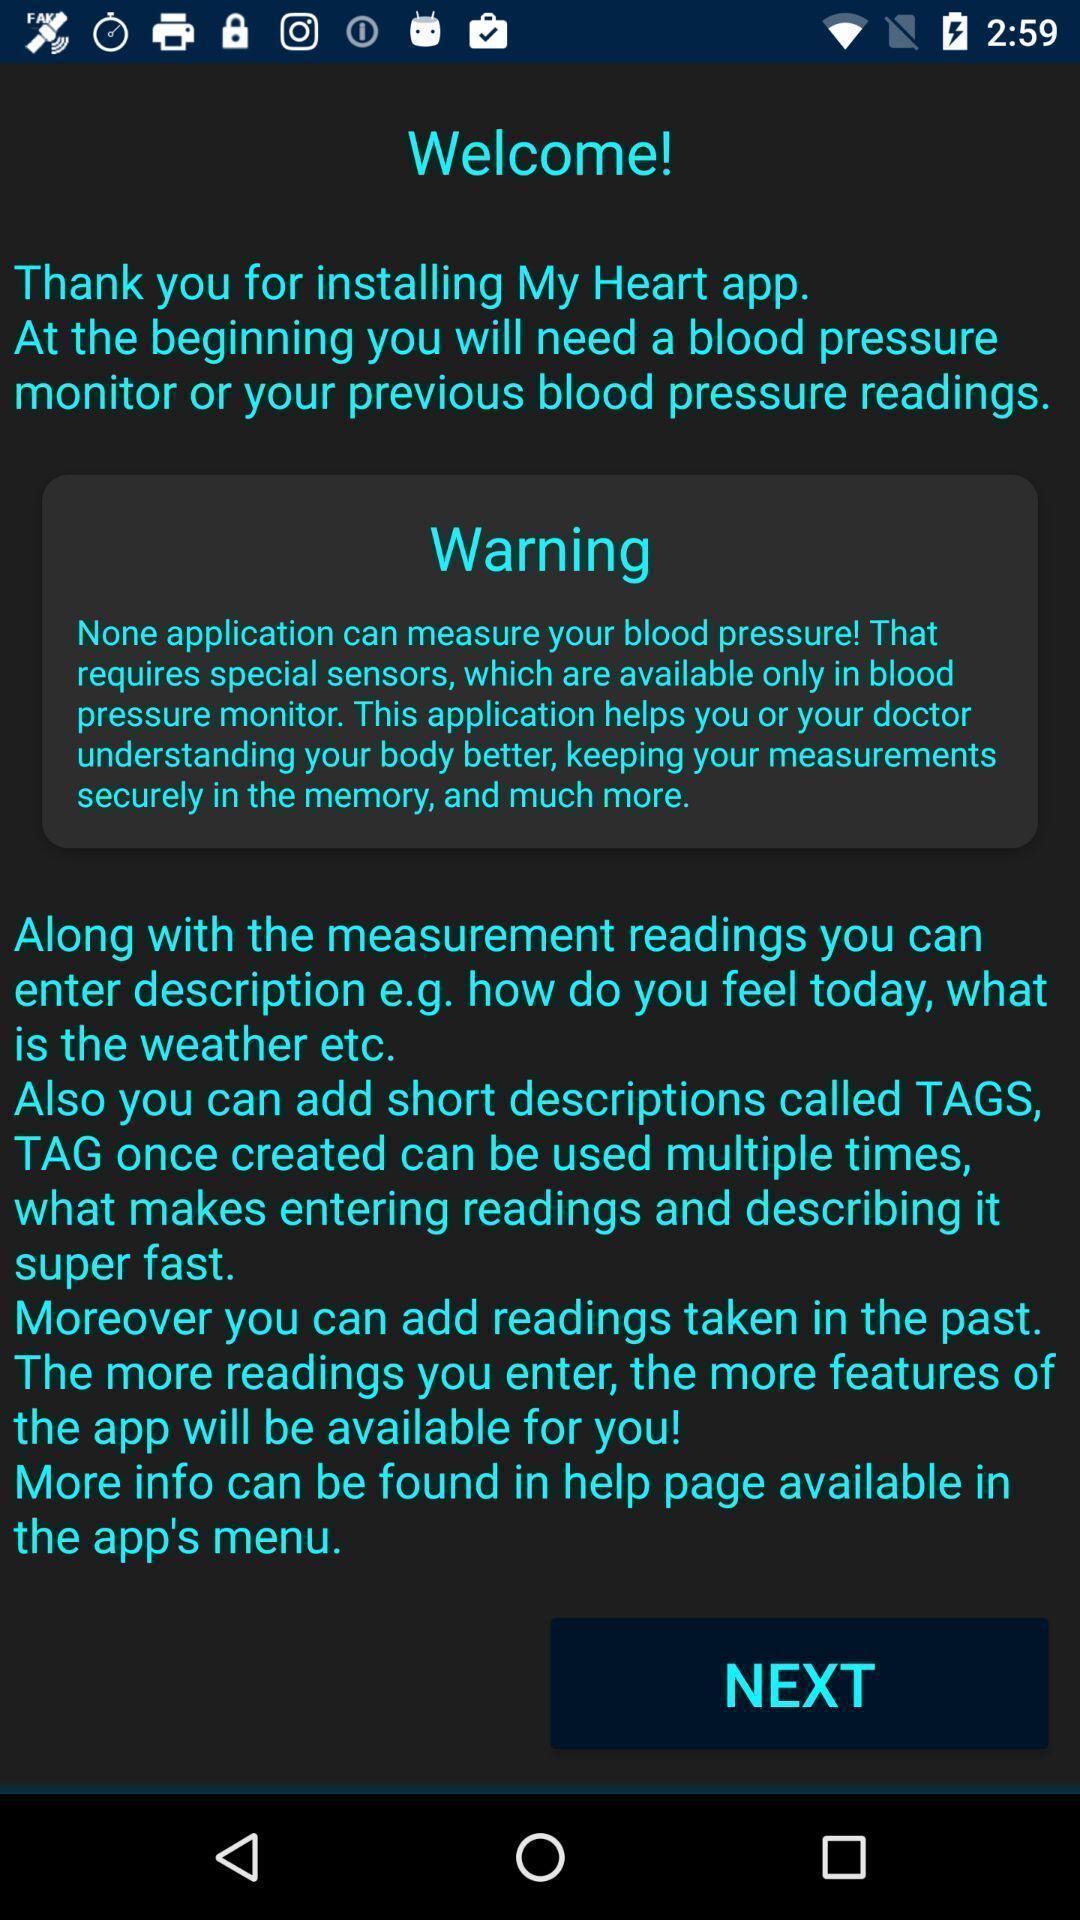Explain what's happening in this screen capture. Welcome screen. 